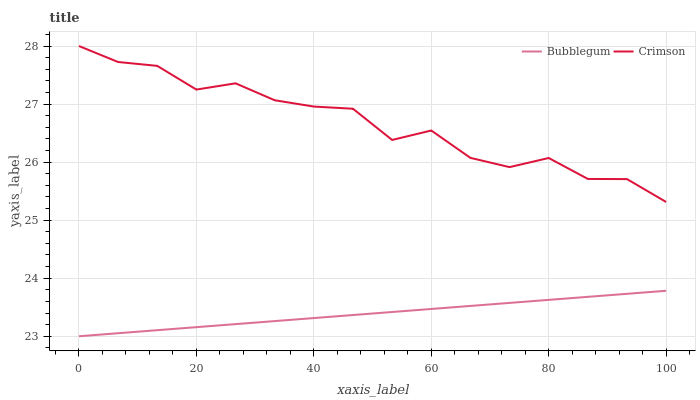Does Bubblegum have the minimum area under the curve?
Answer yes or no. Yes. Does Crimson have the maximum area under the curve?
Answer yes or no. Yes. Does Bubblegum have the maximum area under the curve?
Answer yes or no. No. Is Bubblegum the smoothest?
Answer yes or no. Yes. Is Crimson the roughest?
Answer yes or no. Yes. Is Bubblegum the roughest?
Answer yes or no. No. Does Bubblegum have the lowest value?
Answer yes or no. Yes. Does Crimson have the highest value?
Answer yes or no. Yes. Does Bubblegum have the highest value?
Answer yes or no. No. Is Bubblegum less than Crimson?
Answer yes or no. Yes. Is Crimson greater than Bubblegum?
Answer yes or no. Yes. Does Bubblegum intersect Crimson?
Answer yes or no. No. 